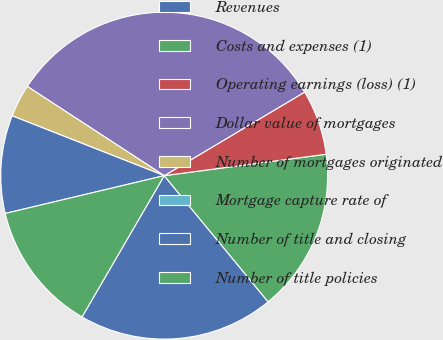Convert chart. <chart><loc_0><loc_0><loc_500><loc_500><pie_chart><fcel>Revenues<fcel>Costs and expenses (1)<fcel>Operating earnings (loss) (1)<fcel>Dollar value of mortgages<fcel>Number of mortgages originated<fcel>Mortgage capture rate of<fcel>Number of title and closing<fcel>Number of title policies<nl><fcel>19.35%<fcel>16.13%<fcel>6.45%<fcel>32.26%<fcel>3.23%<fcel>0.0%<fcel>9.68%<fcel>12.9%<nl></chart> 